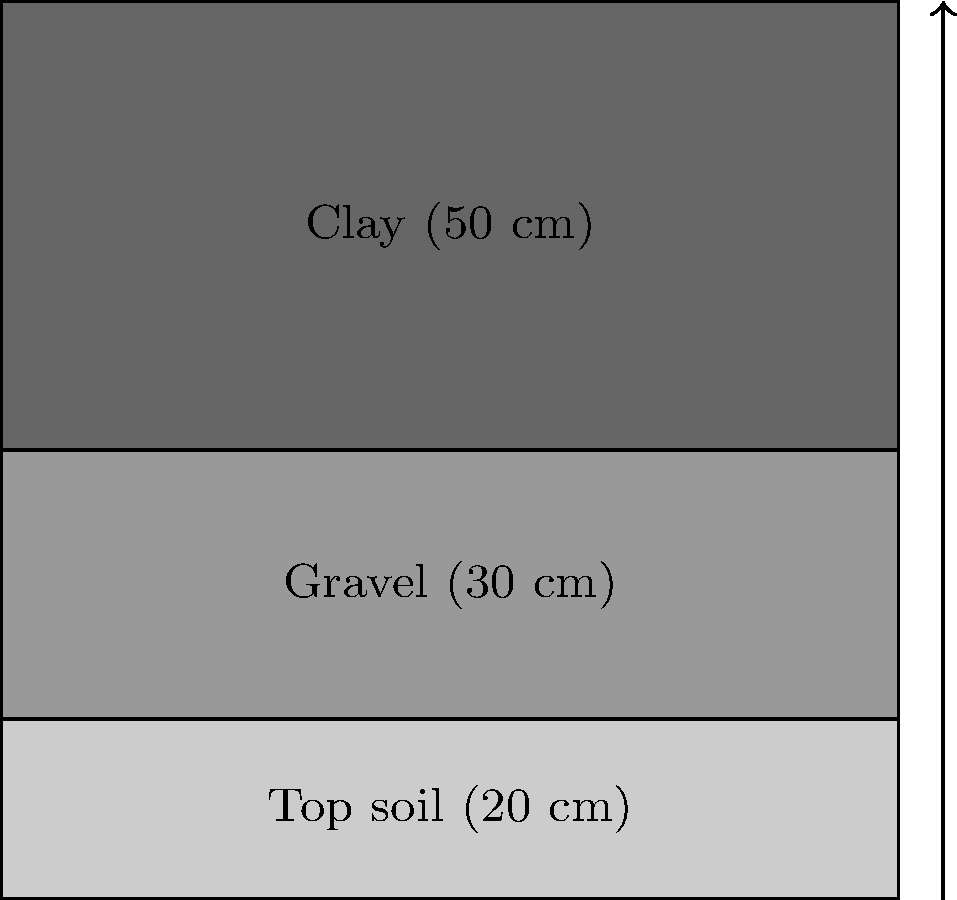For a jazz festival venue, a soil compaction problem needs to be addressed. The soil profile consists of three layers: 20 cm of top soil, 30 cm of gravel, and 50 cm of clay. If the soil has a total depth of 1 m and the compaction ratio for each layer is 0.9, 0.95, and 0.85 respectively, calculate the final depth of the soil profile after compaction. Express your answer in terms of the original depth as a percentage, rounded to the nearest whole number. To solve this problem, we'll follow these steps:

1) First, let's calculate the compacted depth of each layer:

   Top soil: $20 \text{ cm} \times 0.9 = 18 \text{ cm}$
   Gravel: $30 \text{ cm} \times 0.95 = 28.5 \text{ cm}$
   Clay: $50 \text{ cm} \times 0.85 = 42.5 \text{ cm}$

2) Now, let's sum up the compacted depths:

   $18 \text{ cm} + 28.5 \text{ cm} + 42.5 \text{ cm} = 89 \text{ cm}$

3) The original depth was 100 cm (1 m). To express the final depth as a percentage of the original, we use:

   $\frac{\text{Final depth}}{\text{Original depth}} \times 100\% = \frac{89 \text{ cm}}{100 \text{ cm}} \times 100\% = 89\%$

4) Rounding to the nearest whole number:

   $89\% \approx 89\%$ (no change needed)

Thus, after compaction, the soil profile will be 89% of its original depth.
Answer: 89% 